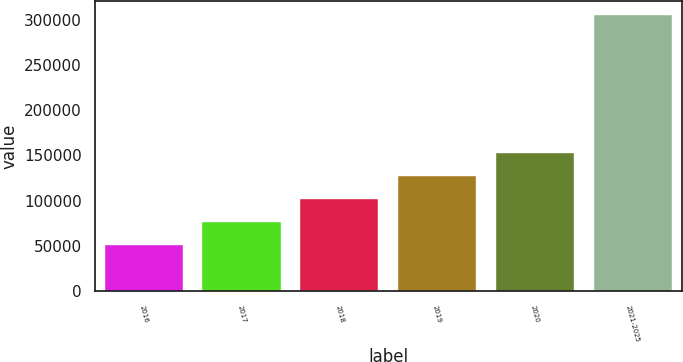Convert chart. <chart><loc_0><loc_0><loc_500><loc_500><bar_chart><fcel>2016<fcel>2017<fcel>2018<fcel>2019<fcel>2020<fcel>2021-2025<nl><fcel>51286<fcel>76661.7<fcel>102037<fcel>127413<fcel>152789<fcel>305043<nl></chart> 